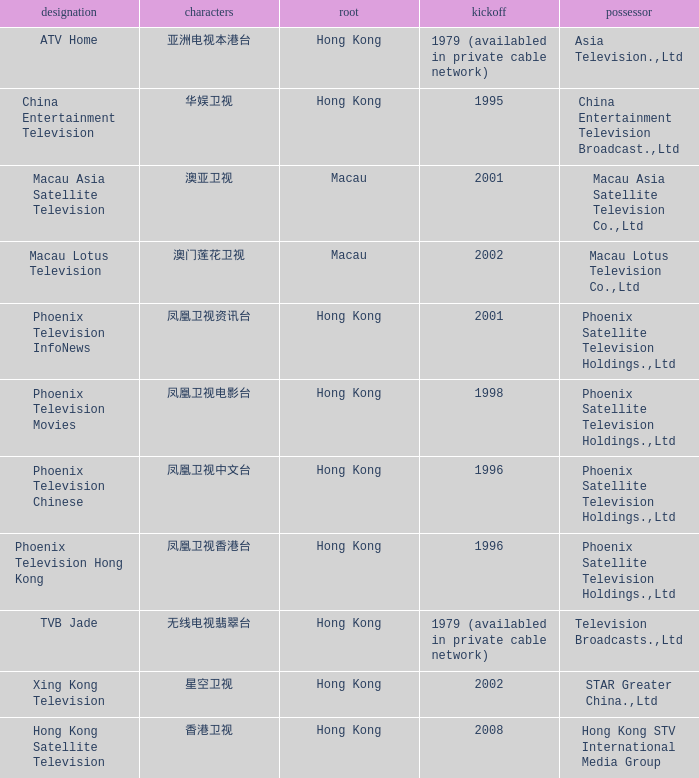What is the Hanzi of Hong Kong in 1998? 凤凰卫视电影台. 